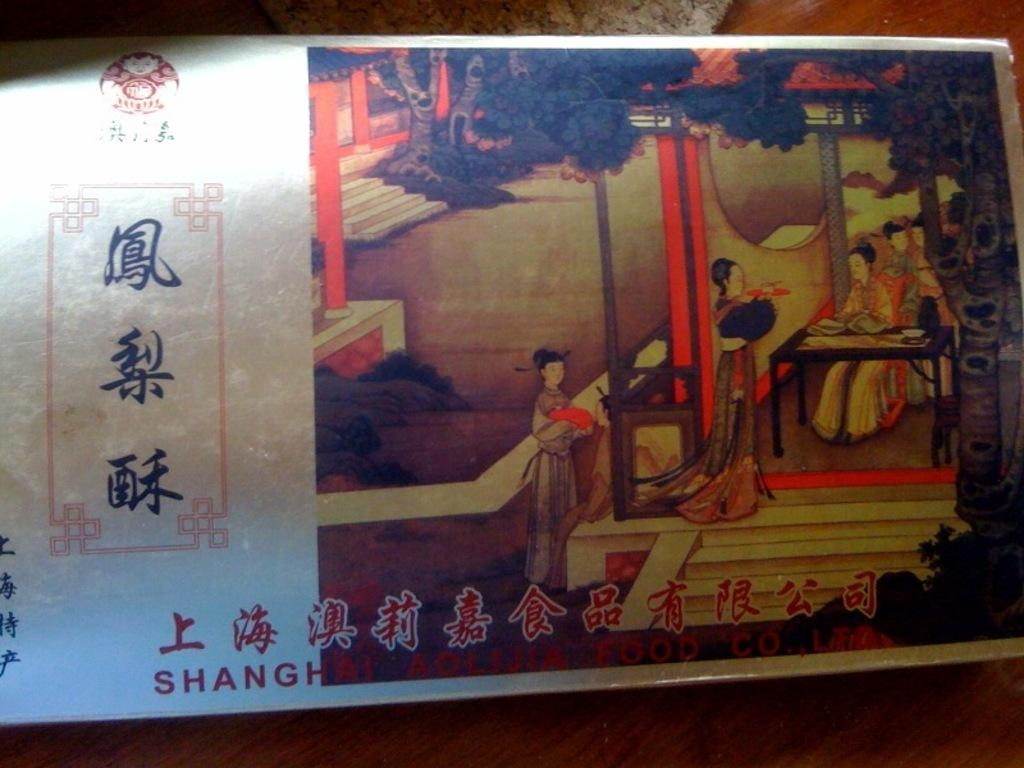What is placed on the table in the image? There is a photo placed on a table in the image. What does the sister of the stranger in the photo say to the self in the image? There is no sister, stranger, or self present in the image, as it only features a photo placed on a table. 